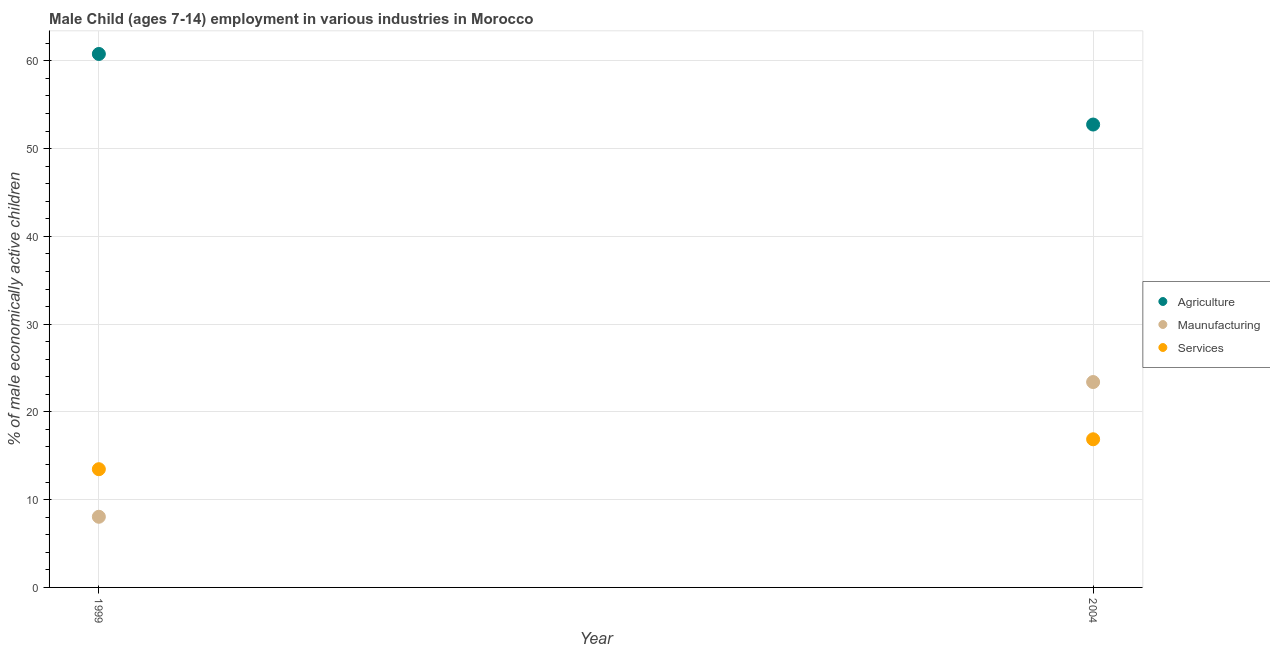How many different coloured dotlines are there?
Provide a short and direct response. 3. Is the number of dotlines equal to the number of legend labels?
Provide a succinct answer. Yes. What is the percentage of economically active children in manufacturing in 2004?
Give a very brief answer. 23.4. Across all years, what is the maximum percentage of economically active children in agriculture?
Ensure brevity in your answer.  60.78. Across all years, what is the minimum percentage of economically active children in services?
Offer a very short reply. 13.47. In which year was the percentage of economically active children in agriculture maximum?
Provide a short and direct response. 1999. In which year was the percentage of economically active children in manufacturing minimum?
Make the answer very short. 1999. What is the total percentage of economically active children in agriculture in the graph?
Give a very brief answer. 113.52. What is the difference between the percentage of economically active children in manufacturing in 1999 and that in 2004?
Offer a terse response. -15.35. What is the difference between the percentage of economically active children in manufacturing in 1999 and the percentage of economically active children in services in 2004?
Your answer should be very brief. -8.83. What is the average percentage of economically active children in services per year?
Make the answer very short. 15.18. In the year 1999, what is the difference between the percentage of economically active children in agriculture and percentage of economically active children in services?
Make the answer very short. 47.31. What is the ratio of the percentage of economically active children in services in 1999 to that in 2004?
Your response must be concise. 0.8. Is the percentage of economically active children in manufacturing strictly greater than the percentage of economically active children in services over the years?
Your response must be concise. No. Is the percentage of economically active children in agriculture strictly less than the percentage of economically active children in manufacturing over the years?
Provide a short and direct response. No. How many dotlines are there?
Keep it short and to the point. 3. How many years are there in the graph?
Offer a very short reply. 2. Are the values on the major ticks of Y-axis written in scientific E-notation?
Provide a succinct answer. No. Does the graph contain grids?
Make the answer very short. Yes. Where does the legend appear in the graph?
Keep it short and to the point. Center right. How many legend labels are there?
Provide a short and direct response. 3. What is the title of the graph?
Your answer should be very brief. Male Child (ages 7-14) employment in various industries in Morocco. What is the label or title of the Y-axis?
Keep it short and to the point. % of male economically active children. What is the % of male economically active children of Agriculture in 1999?
Provide a succinct answer. 60.78. What is the % of male economically active children in Maunufacturing in 1999?
Keep it short and to the point. 8.05. What is the % of male economically active children of Services in 1999?
Provide a short and direct response. 13.47. What is the % of male economically active children in Agriculture in 2004?
Your response must be concise. 52.74. What is the % of male economically active children in Maunufacturing in 2004?
Provide a short and direct response. 23.4. What is the % of male economically active children in Services in 2004?
Ensure brevity in your answer.  16.88. Across all years, what is the maximum % of male economically active children in Agriculture?
Make the answer very short. 60.78. Across all years, what is the maximum % of male economically active children of Maunufacturing?
Your answer should be compact. 23.4. Across all years, what is the maximum % of male economically active children in Services?
Your response must be concise. 16.88. Across all years, what is the minimum % of male economically active children in Agriculture?
Provide a short and direct response. 52.74. Across all years, what is the minimum % of male economically active children of Maunufacturing?
Keep it short and to the point. 8.05. Across all years, what is the minimum % of male economically active children of Services?
Ensure brevity in your answer.  13.47. What is the total % of male economically active children of Agriculture in the graph?
Ensure brevity in your answer.  113.52. What is the total % of male economically active children in Maunufacturing in the graph?
Ensure brevity in your answer.  31.45. What is the total % of male economically active children of Services in the graph?
Offer a terse response. 30.35. What is the difference between the % of male economically active children of Agriculture in 1999 and that in 2004?
Ensure brevity in your answer.  8.04. What is the difference between the % of male economically active children of Maunufacturing in 1999 and that in 2004?
Provide a succinct answer. -15.35. What is the difference between the % of male economically active children in Services in 1999 and that in 2004?
Provide a succinct answer. -3.41. What is the difference between the % of male economically active children of Agriculture in 1999 and the % of male economically active children of Maunufacturing in 2004?
Make the answer very short. 37.38. What is the difference between the % of male economically active children in Agriculture in 1999 and the % of male economically active children in Services in 2004?
Provide a short and direct response. 43.9. What is the difference between the % of male economically active children in Maunufacturing in 1999 and the % of male economically active children in Services in 2004?
Your answer should be compact. -8.83. What is the average % of male economically active children of Agriculture per year?
Make the answer very short. 56.76. What is the average % of male economically active children of Maunufacturing per year?
Ensure brevity in your answer.  15.72. What is the average % of male economically active children in Services per year?
Your response must be concise. 15.18. In the year 1999, what is the difference between the % of male economically active children of Agriculture and % of male economically active children of Maunufacturing?
Ensure brevity in your answer.  52.73. In the year 1999, what is the difference between the % of male economically active children of Agriculture and % of male economically active children of Services?
Offer a very short reply. 47.31. In the year 1999, what is the difference between the % of male economically active children in Maunufacturing and % of male economically active children in Services?
Ensure brevity in your answer.  -5.42. In the year 2004, what is the difference between the % of male economically active children in Agriculture and % of male economically active children in Maunufacturing?
Provide a succinct answer. 29.34. In the year 2004, what is the difference between the % of male economically active children of Agriculture and % of male economically active children of Services?
Keep it short and to the point. 35.86. In the year 2004, what is the difference between the % of male economically active children of Maunufacturing and % of male economically active children of Services?
Provide a succinct answer. 6.52. What is the ratio of the % of male economically active children of Agriculture in 1999 to that in 2004?
Keep it short and to the point. 1.15. What is the ratio of the % of male economically active children of Maunufacturing in 1999 to that in 2004?
Give a very brief answer. 0.34. What is the ratio of the % of male economically active children of Services in 1999 to that in 2004?
Provide a succinct answer. 0.8. What is the difference between the highest and the second highest % of male economically active children in Agriculture?
Your answer should be very brief. 8.04. What is the difference between the highest and the second highest % of male economically active children of Maunufacturing?
Give a very brief answer. 15.35. What is the difference between the highest and the second highest % of male economically active children of Services?
Keep it short and to the point. 3.41. What is the difference between the highest and the lowest % of male economically active children in Agriculture?
Give a very brief answer. 8.04. What is the difference between the highest and the lowest % of male economically active children of Maunufacturing?
Your answer should be very brief. 15.35. What is the difference between the highest and the lowest % of male economically active children in Services?
Your response must be concise. 3.41. 